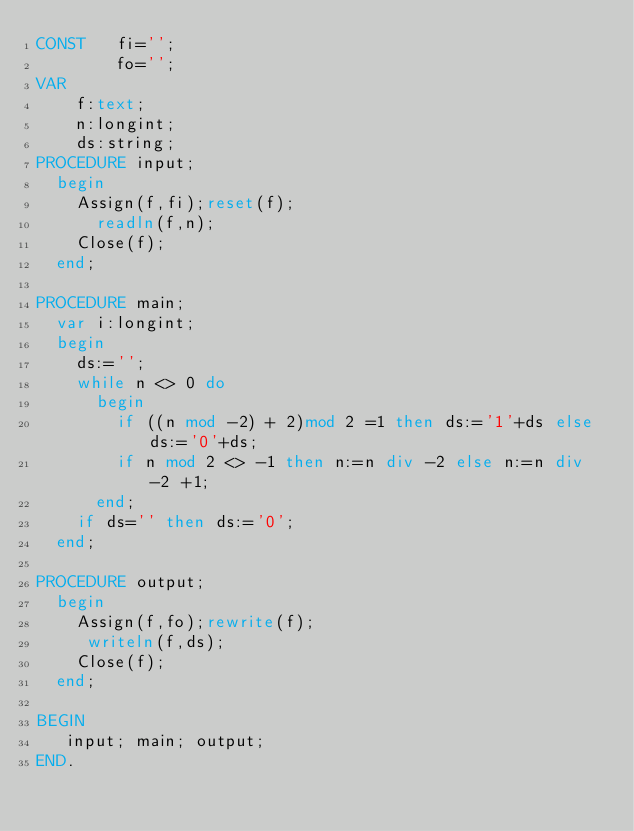Convert code to text. <code><loc_0><loc_0><loc_500><loc_500><_Pascal_>CONST   fi='';
        fo='';
VAR
    f:text;
    n:longint;
    ds:string;
PROCEDURE input;
  begin
    Assign(f,fi);reset(f);
      readln(f,n);
    Close(f);
  end;

PROCEDURE main;
  var i:longint;
  begin
    ds:='';
    while n <> 0 do
      begin
        if ((n mod -2) + 2)mod 2 =1 then ds:='1'+ds else ds:='0'+ds;
        if n mod 2 <> -1 then n:=n div -2 else n:=n div -2 +1;
      end;
    if ds='' then ds:='0';
  end;

PROCEDURE output;
  begin
    Assign(f,fo);rewrite(f);
     writeln(f,ds);
    Close(f);
  end;

BEGIN
   input; main; output;
END.
</code> 